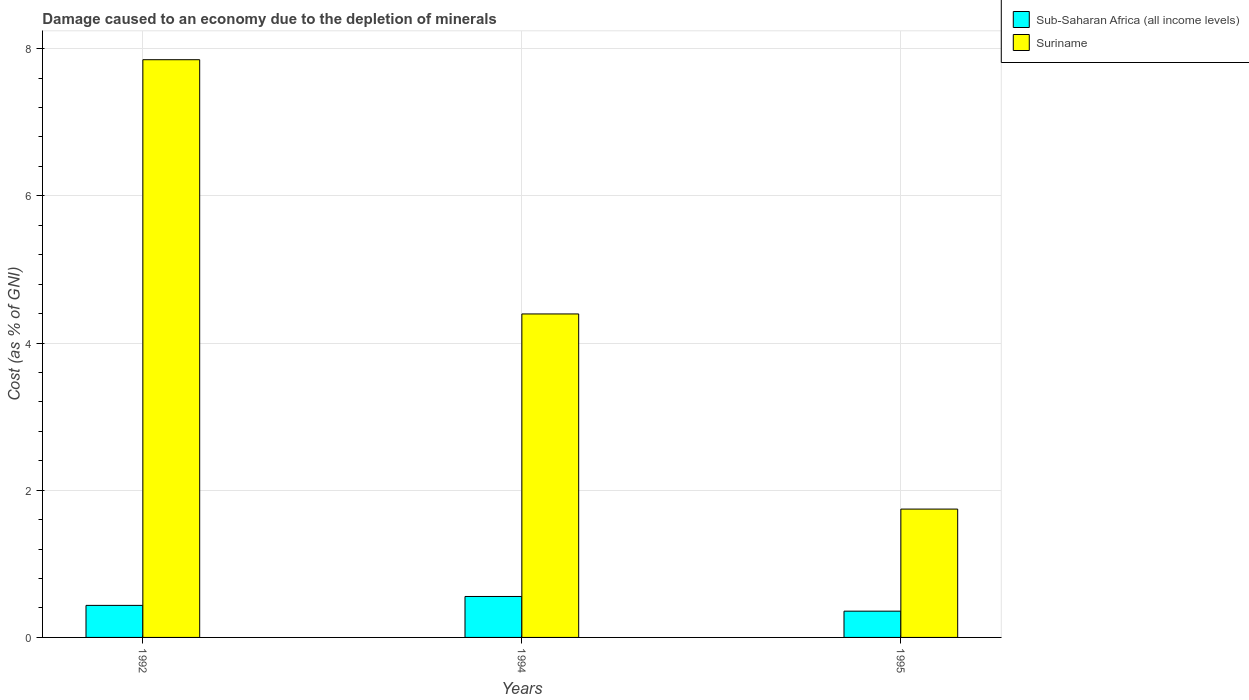How many different coloured bars are there?
Ensure brevity in your answer.  2. Are the number of bars on each tick of the X-axis equal?
Your answer should be very brief. Yes. What is the cost of damage caused due to the depletion of minerals in Suriname in 1992?
Give a very brief answer. 7.85. Across all years, what is the maximum cost of damage caused due to the depletion of minerals in Suriname?
Keep it short and to the point. 7.85. Across all years, what is the minimum cost of damage caused due to the depletion of minerals in Suriname?
Offer a very short reply. 1.74. In which year was the cost of damage caused due to the depletion of minerals in Sub-Saharan Africa (all income levels) maximum?
Offer a terse response. 1994. What is the total cost of damage caused due to the depletion of minerals in Sub-Saharan Africa (all income levels) in the graph?
Offer a very short reply. 1.35. What is the difference between the cost of damage caused due to the depletion of minerals in Suriname in 1994 and that in 1995?
Your answer should be very brief. 2.65. What is the difference between the cost of damage caused due to the depletion of minerals in Suriname in 1992 and the cost of damage caused due to the depletion of minerals in Sub-Saharan Africa (all income levels) in 1994?
Your answer should be very brief. 7.29. What is the average cost of damage caused due to the depletion of minerals in Sub-Saharan Africa (all income levels) per year?
Make the answer very short. 0.45. In the year 1992, what is the difference between the cost of damage caused due to the depletion of minerals in Suriname and cost of damage caused due to the depletion of minerals in Sub-Saharan Africa (all income levels)?
Ensure brevity in your answer.  7.41. In how many years, is the cost of damage caused due to the depletion of minerals in Sub-Saharan Africa (all income levels) greater than 0.8 %?
Offer a terse response. 0. What is the ratio of the cost of damage caused due to the depletion of minerals in Sub-Saharan Africa (all income levels) in 1992 to that in 1995?
Offer a terse response. 1.22. Is the cost of damage caused due to the depletion of minerals in Sub-Saharan Africa (all income levels) in 1992 less than that in 1995?
Provide a succinct answer. No. Is the difference between the cost of damage caused due to the depletion of minerals in Suriname in 1994 and 1995 greater than the difference between the cost of damage caused due to the depletion of minerals in Sub-Saharan Africa (all income levels) in 1994 and 1995?
Offer a very short reply. Yes. What is the difference between the highest and the second highest cost of damage caused due to the depletion of minerals in Sub-Saharan Africa (all income levels)?
Offer a very short reply. 0.12. What is the difference between the highest and the lowest cost of damage caused due to the depletion of minerals in Suriname?
Give a very brief answer. 6.11. What does the 2nd bar from the left in 1995 represents?
Your response must be concise. Suriname. What does the 1st bar from the right in 1995 represents?
Offer a terse response. Suriname. What is the difference between two consecutive major ticks on the Y-axis?
Your response must be concise. 2. Are the values on the major ticks of Y-axis written in scientific E-notation?
Provide a short and direct response. No. How are the legend labels stacked?
Ensure brevity in your answer.  Vertical. What is the title of the graph?
Your response must be concise. Damage caused to an economy due to the depletion of minerals. Does "Israel" appear as one of the legend labels in the graph?
Ensure brevity in your answer.  No. What is the label or title of the Y-axis?
Your response must be concise. Cost (as % of GNI). What is the Cost (as % of GNI) of Sub-Saharan Africa (all income levels) in 1992?
Ensure brevity in your answer.  0.44. What is the Cost (as % of GNI) in Suriname in 1992?
Keep it short and to the point. 7.85. What is the Cost (as % of GNI) in Sub-Saharan Africa (all income levels) in 1994?
Offer a terse response. 0.56. What is the Cost (as % of GNI) in Suriname in 1994?
Make the answer very short. 4.4. What is the Cost (as % of GNI) of Sub-Saharan Africa (all income levels) in 1995?
Provide a succinct answer. 0.36. What is the Cost (as % of GNI) of Suriname in 1995?
Provide a succinct answer. 1.74. Across all years, what is the maximum Cost (as % of GNI) of Sub-Saharan Africa (all income levels)?
Your answer should be compact. 0.56. Across all years, what is the maximum Cost (as % of GNI) in Suriname?
Make the answer very short. 7.85. Across all years, what is the minimum Cost (as % of GNI) of Sub-Saharan Africa (all income levels)?
Provide a short and direct response. 0.36. Across all years, what is the minimum Cost (as % of GNI) in Suriname?
Offer a very short reply. 1.74. What is the total Cost (as % of GNI) in Sub-Saharan Africa (all income levels) in the graph?
Give a very brief answer. 1.35. What is the total Cost (as % of GNI) of Suriname in the graph?
Offer a terse response. 13.99. What is the difference between the Cost (as % of GNI) in Sub-Saharan Africa (all income levels) in 1992 and that in 1994?
Your response must be concise. -0.12. What is the difference between the Cost (as % of GNI) in Suriname in 1992 and that in 1994?
Your answer should be very brief. 3.45. What is the difference between the Cost (as % of GNI) in Sub-Saharan Africa (all income levels) in 1992 and that in 1995?
Ensure brevity in your answer.  0.08. What is the difference between the Cost (as % of GNI) in Suriname in 1992 and that in 1995?
Give a very brief answer. 6.11. What is the difference between the Cost (as % of GNI) in Sub-Saharan Africa (all income levels) in 1994 and that in 1995?
Your answer should be compact. 0.2. What is the difference between the Cost (as % of GNI) of Suriname in 1994 and that in 1995?
Provide a succinct answer. 2.65. What is the difference between the Cost (as % of GNI) of Sub-Saharan Africa (all income levels) in 1992 and the Cost (as % of GNI) of Suriname in 1994?
Offer a very short reply. -3.96. What is the difference between the Cost (as % of GNI) of Sub-Saharan Africa (all income levels) in 1992 and the Cost (as % of GNI) of Suriname in 1995?
Make the answer very short. -1.31. What is the difference between the Cost (as % of GNI) of Sub-Saharan Africa (all income levels) in 1994 and the Cost (as % of GNI) of Suriname in 1995?
Provide a short and direct response. -1.19. What is the average Cost (as % of GNI) of Sub-Saharan Africa (all income levels) per year?
Your answer should be very brief. 0.45. What is the average Cost (as % of GNI) in Suriname per year?
Keep it short and to the point. 4.66. In the year 1992, what is the difference between the Cost (as % of GNI) of Sub-Saharan Africa (all income levels) and Cost (as % of GNI) of Suriname?
Your answer should be compact. -7.41. In the year 1994, what is the difference between the Cost (as % of GNI) in Sub-Saharan Africa (all income levels) and Cost (as % of GNI) in Suriname?
Your response must be concise. -3.84. In the year 1995, what is the difference between the Cost (as % of GNI) of Sub-Saharan Africa (all income levels) and Cost (as % of GNI) of Suriname?
Keep it short and to the point. -1.39. What is the ratio of the Cost (as % of GNI) in Sub-Saharan Africa (all income levels) in 1992 to that in 1994?
Keep it short and to the point. 0.78. What is the ratio of the Cost (as % of GNI) of Suriname in 1992 to that in 1994?
Your answer should be very brief. 1.79. What is the ratio of the Cost (as % of GNI) in Sub-Saharan Africa (all income levels) in 1992 to that in 1995?
Your response must be concise. 1.22. What is the ratio of the Cost (as % of GNI) in Suriname in 1992 to that in 1995?
Keep it short and to the point. 4.5. What is the ratio of the Cost (as % of GNI) in Sub-Saharan Africa (all income levels) in 1994 to that in 1995?
Offer a very short reply. 1.56. What is the ratio of the Cost (as % of GNI) in Suriname in 1994 to that in 1995?
Offer a terse response. 2.52. What is the difference between the highest and the second highest Cost (as % of GNI) of Sub-Saharan Africa (all income levels)?
Your response must be concise. 0.12. What is the difference between the highest and the second highest Cost (as % of GNI) in Suriname?
Your response must be concise. 3.45. What is the difference between the highest and the lowest Cost (as % of GNI) in Sub-Saharan Africa (all income levels)?
Your answer should be compact. 0.2. What is the difference between the highest and the lowest Cost (as % of GNI) in Suriname?
Offer a very short reply. 6.11. 